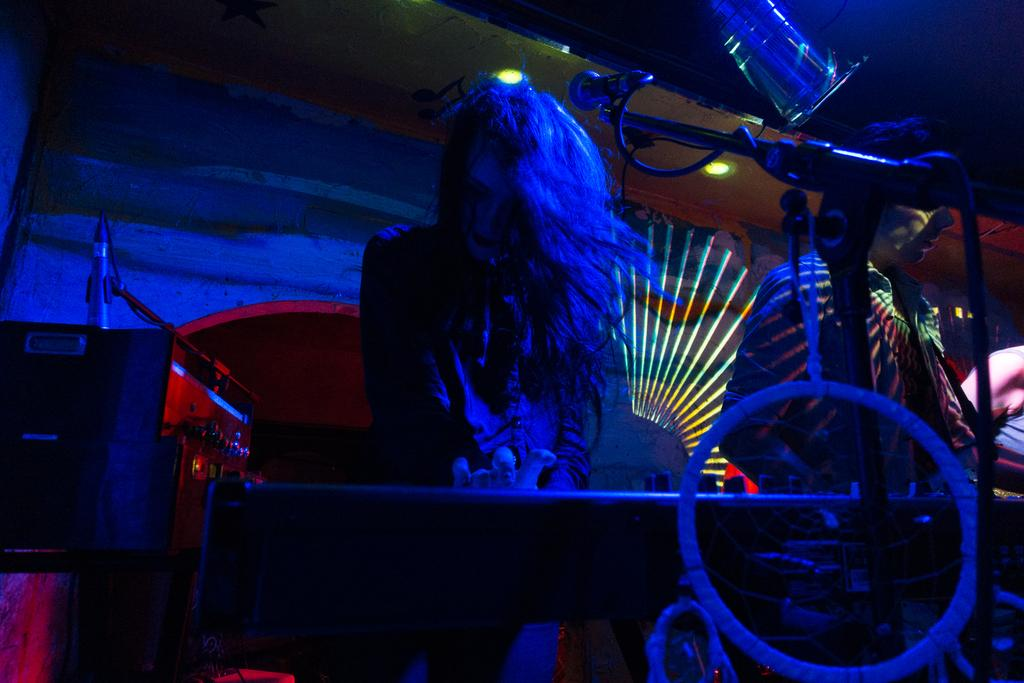Who is the main subject in the image? There is a woman in the image. What is the woman doing in the image? The woman is playing music. What object is to the left of the woman? There is a microphone to the left of the woman. What color light can be seen in the image? There is a blue color light in the image. Who is to the right of the woman? There is a man to the right of the woman. Can you see the woman's sister in the image? There is no mention of a sister in the image, so we cannot determine if she is present or not. What type of board is the woman using to play music? There is no board mentioned or visible in the image; the woman is playing music without a board. 